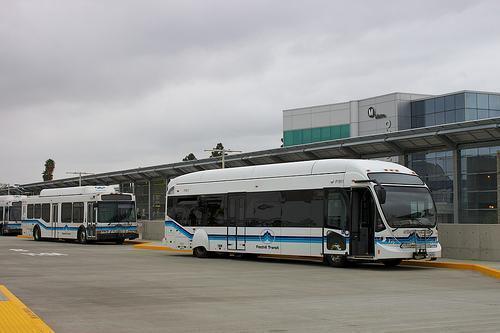How many buses are there?
Give a very brief answer. 2. 